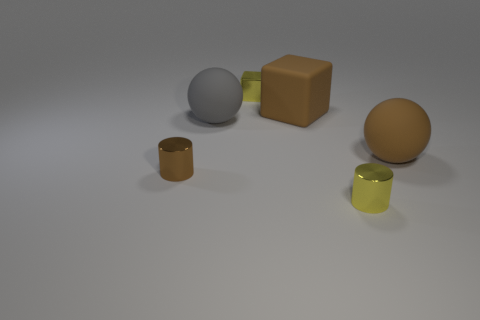What colors are present in the objects displayed in this image? There are a variety of colors displayed among the objects. We have a light gray sphere, a mustard-colored cube, a brown sphere, a small brown cylinder, and a taller lime-green cylinder. 